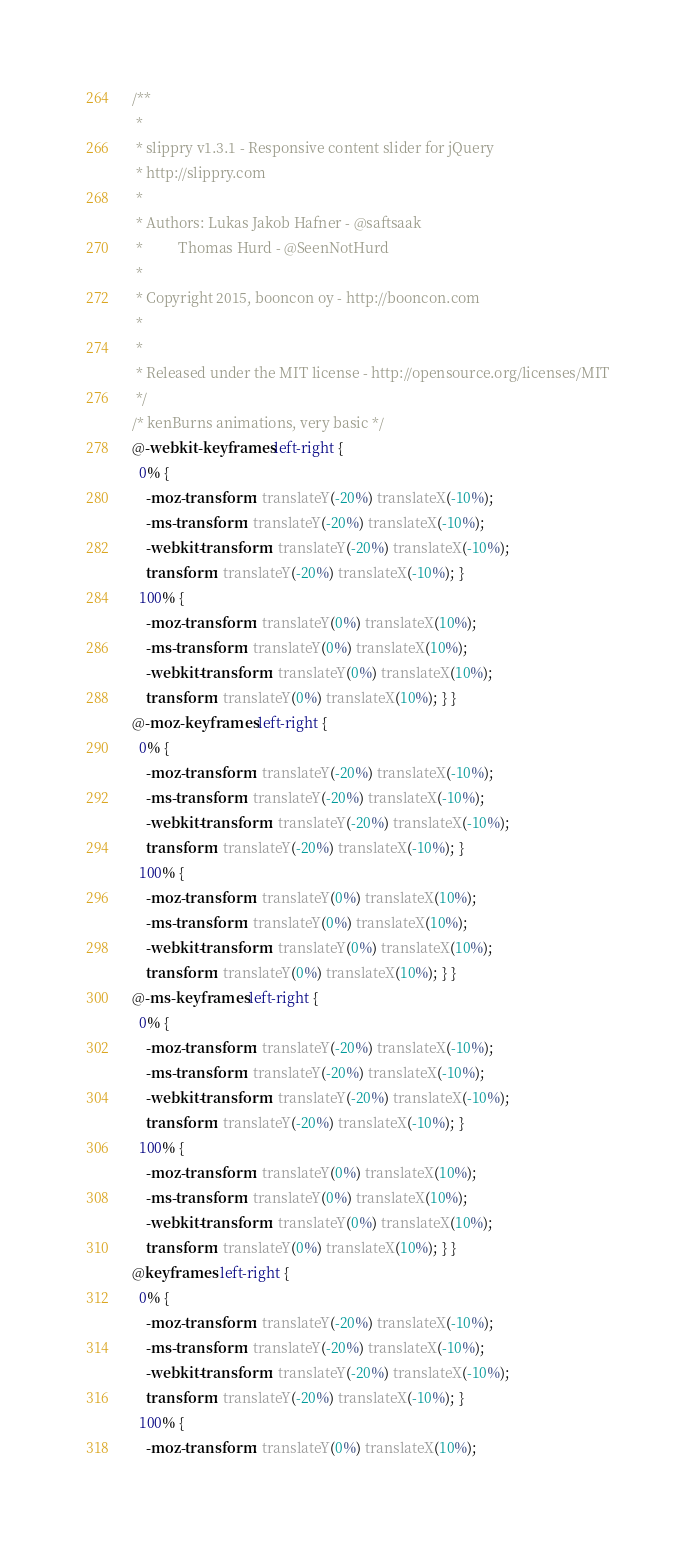Convert code to text. <code><loc_0><loc_0><loc_500><loc_500><_CSS_>/**
 *
 * slippry v1.3.1 - Responsive content slider for jQuery
 * http://slippry.com
 *
 * Authors: Lukas Jakob Hafner - @saftsaak
 *          Thomas Hurd - @SeenNotHurd
 *
 * Copyright 2015, booncon oy - http://booncon.com
 *
 *
 * Released under the MIT license - http://opensource.org/licenses/MIT
 */
/* kenBurns animations, very basic */
@-webkit-keyframes left-right {
  0% {
    -moz-transform: translateY(-20%) translateX(-10%);
    -ms-transform: translateY(-20%) translateX(-10%);
    -webkit-transform: translateY(-20%) translateX(-10%);
    transform: translateY(-20%) translateX(-10%); }
  100% {
    -moz-transform: translateY(0%) translateX(10%);
    -ms-transform: translateY(0%) translateX(10%);
    -webkit-transform: translateY(0%) translateX(10%);
    transform: translateY(0%) translateX(10%); } }
@-moz-keyframes left-right {
  0% {
    -moz-transform: translateY(-20%) translateX(-10%);
    -ms-transform: translateY(-20%) translateX(-10%);
    -webkit-transform: translateY(-20%) translateX(-10%);
    transform: translateY(-20%) translateX(-10%); }
  100% {
    -moz-transform: translateY(0%) translateX(10%);
    -ms-transform: translateY(0%) translateX(10%);
    -webkit-transform: translateY(0%) translateX(10%);
    transform: translateY(0%) translateX(10%); } }
@-ms-keyframes left-right {
  0% {
    -moz-transform: translateY(-20%) translateX(-10%);
    -ms-transform: translateY(-20%) translateX(-10%);
    -webkit-transform: translateY(-20%) translateX(-10%);
    transform: translateY(-20%) translateX(-10%); }
  100% {
    -moz-transform: translateY(0%) translateX(10%);
    -ms-transform: translateY(0%) translateX(10%);
    -webkit-transform: translateY(0%) translateX(10%);
    transform: translateY(0%) translateX(10%); } }
@keyframes left-right {
  0% {
    -moz-transform: translateY(-20%) translateX(-10%);
    -ms-transform: translateY(-20%) translateX(-10%);
    -webkit-transform: translateY(-20%) translateX(-10%);
    transform: translateY(-20%) translateX(-10%); }
  100% {
    -moz-transform: translateY(0%) translateX(10%);</code> 